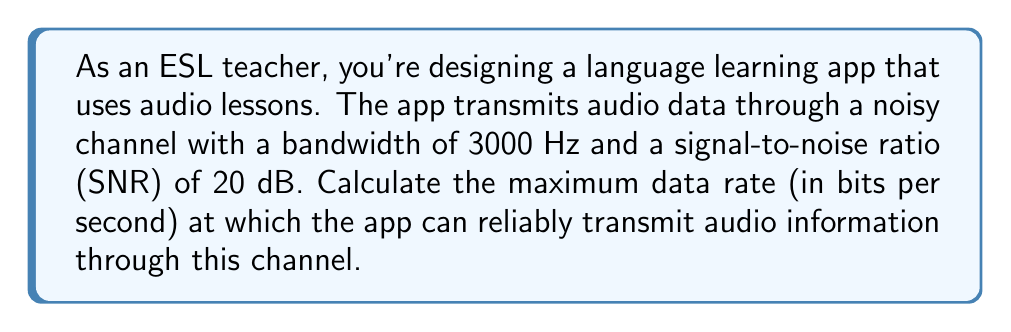Help me with this question. To solve this problem, we'll use the Shannon-Hartley theorem, which gives us the channel capacity for a noisy communication system. The theorem is expressed as:

$$C = B \log_2(1 + SNR)$$

Where:
$C$ = Channel capacity (bits per second)
$B$ = Bandwidth (Hz)
$SNR$ = Signal-to-Noise Ratio (linear scale)

Given:
- Bandwidth $(B) = 3000$ Hz
- SNR = 20 dB

Step 1: Convert SNR from decibels to linear scale
The SNR is given in decibels (dB), but we need it in linear scale for the formula. The conversion is:

$$SNR_{linear} = 10^{\frac{SNR_{dB}}{10}}$$

$$SNR_{linear} = 10^{\frac{20}{10}} = 10^2 = 100$$

Step 2: Apply the Shannon-Hartley theorem
Now we can plug the values into the formula:

$$C = 3000 \log_2(1 + 100)$$

Step 3: Calculate the logarithm
$$\log_2(101) \approx 6.658211$$

Step 4: Multiply by the bandwidth
$$C = 3000 \times 6.658211 \approx 19,974.63$$

Therefore, the channel capacity is approximately 19,974.63 bits per second.
Answer: The maximum data rate at which the app can reliably transmit audio information through the given channel is approximately 19,975 bits per second. 